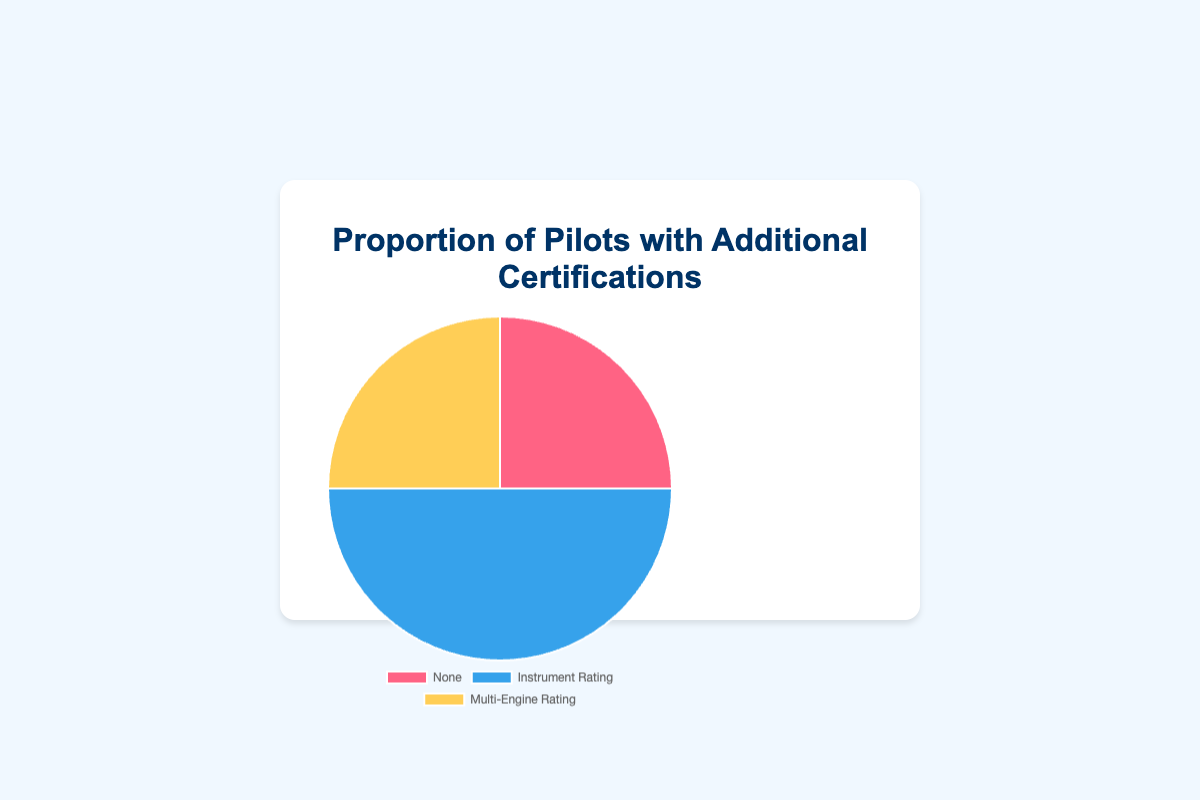What proportion of pilots have an Instrument Rating? According to the pie chart, the slice labeled "Instrument Rating" represents the proportion of pilots with this certification, which is indicated as 50%.
Answer: 50% Which certification is held by the largest proportion of pilots? The pie chart shows that the "Instrument Rating" slice is the largest with a proportion of 50%, which is greater than the other slices for "None" and "Multi-Engine Rating".
Answer: Instrument Rating What is the combined proportion of pilots with either "None" or "Multi-Engine Rating" certifications? The pie chart indicates that pilots with "None" certification make up 25% and those with "Multi-Engine Rating" make up another 25%. Adding these together gives a combined proportion of 25% + 25% = 50%.
Answer: 50% Compare the proportions of pilots with "None" and "Multi-Engine Rating" certifications. Are they equal? By visually assessing the pie chart, the slices for "None" and "Multi-Engine Rating" are identical in size, both representing 25%.
Answer: Yes, they are equal If you exclude pilots with "Instrument Rating", what percentage of the remaining pilots have "Multi-Engine Rating"? Excluding pilots with "Instrument Rating" (50%), the remaining pilots account for 100% - 50% = 50%. Out of these, 25% have "Multi-Engine Rating", so the percentage is (25% / 50%) * 100 = 50%.
Answer: 50% Describe the colors associated with each certification in the pie chart. In the pie chart, pilots with "None" certification are represented by red, "Instrument Rating" by blue, and "Multi-Engine Rating" by yellow.
Answer: Red for None, Blue for Instrument Rating, Yellow for Multi-Engine Rating Which certifications together account for the same total proportion as the "Instrument Rating" certification alone? The proportions for "None" and "Multi-Engine Rating" are each 25%. Together, their combined proportion is 25% + 25% = 50%, which matches the "Instrument Rating" proportion of 50%.
Answer: None and Multi-Engine Rating together Is the proportion of pilots without any additional certification equal to the proportion of those with "Multi-Engine Rating"? As seen in the pie chart, both "None" and "Multi-Engine Rating" certifications have equal proportions of 25%.
Answer: Yes, they are equal What proportion of pilots have at least one additional certification? The pie chart shows that pilots with "Instrument Rating" make up 50% and those with "Multi-Engine Rating" make up 25%. Adding these gives a total proportion of 50% + 25% = 75%.
Answer: 75% What is the visual characteristic that helps differentiate the "Instrument Rating" certification in the pie chart? The "Instrument Rating" certification slice is the largest and is colored blue, making it easily distinguishable visually from the other slices.
Answer: It is the largest slice and colored blue 